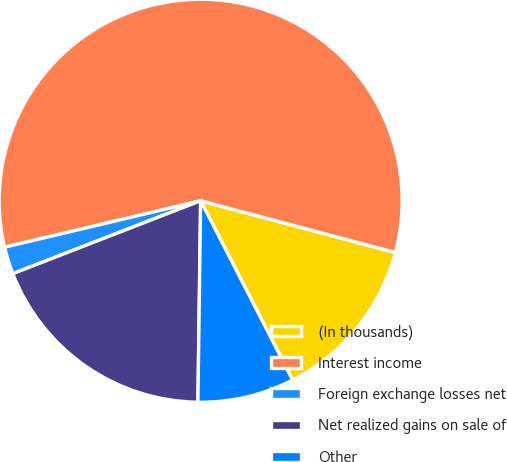Convert chart to OTSL. <chart><loc_0><loc_0><loc_500><loc_500><pie_chart><fcel>(In thousands)<fcel>Interest income<fcel>Foreign exchange losses net<fcel>Net realized gains on sale of<fcel>Other<nl><fcel>13.32%<fcel>57.84%<fcel>2.19%<fcel>18.89%<fcel>7.76%<nl></chart> 